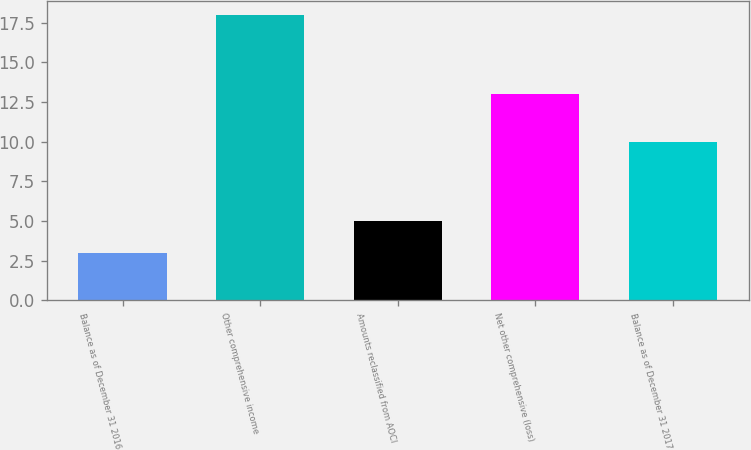Convert chart to OTSL. <chart><loc_0><loc_0><loc_500><loc_500><bar_chart><fcel>Balance as of December 31 2016<fcel>Other comprehensive income<fcel>Amounts reclassified from AOCI<fcel>Net other comprehensive (loss)<fcel>Balance as of December 31 2017<nl><fcel>3<fcel>18<fcel>5<fcel>13<fcel>10<nl></chart> 